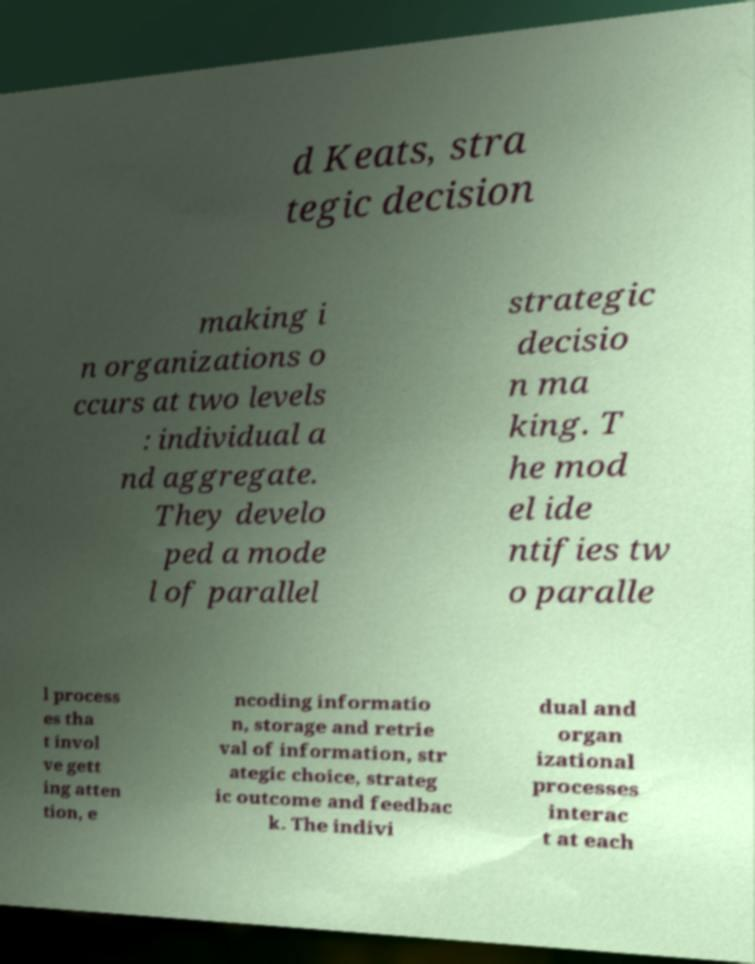I need the written content from this picture converted into text. Can you do that? d Keats, stra tegic decision making i n organizations o ccurs at two levels : individual a nd aggregate. They develo ped a mode l of parallel strategic decisio n ma king. T he mod el ide ntifies tw o paralle l process es tha t invol ve gett ing atten tion, e ncoding informatio n, storage and retrie val of information, str ategic choice, strateg ic outcome and feedbac k. The indivi dual and organ izational processes interac t at each 